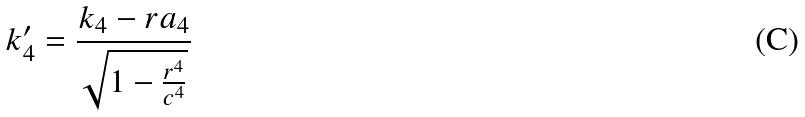<formula> <loc_0><loc_0><loc_500><loc_500>k _ { 4 } ^ { \prime } = \frac { k _ { 4 } - r a _ { 4 } } { \sqrt { 1 - \frac { r ^ { 4 } } { c ^ { 4 } } } }</formula> 